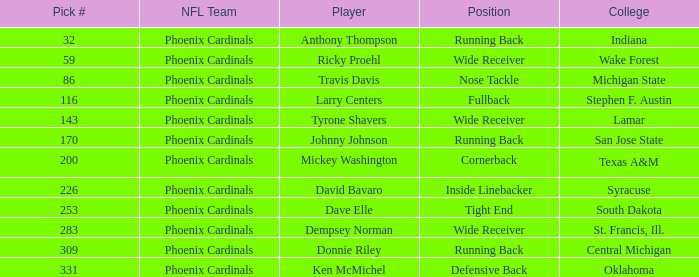Which competitor was a running back from san jose state? Johnny Johnson. 